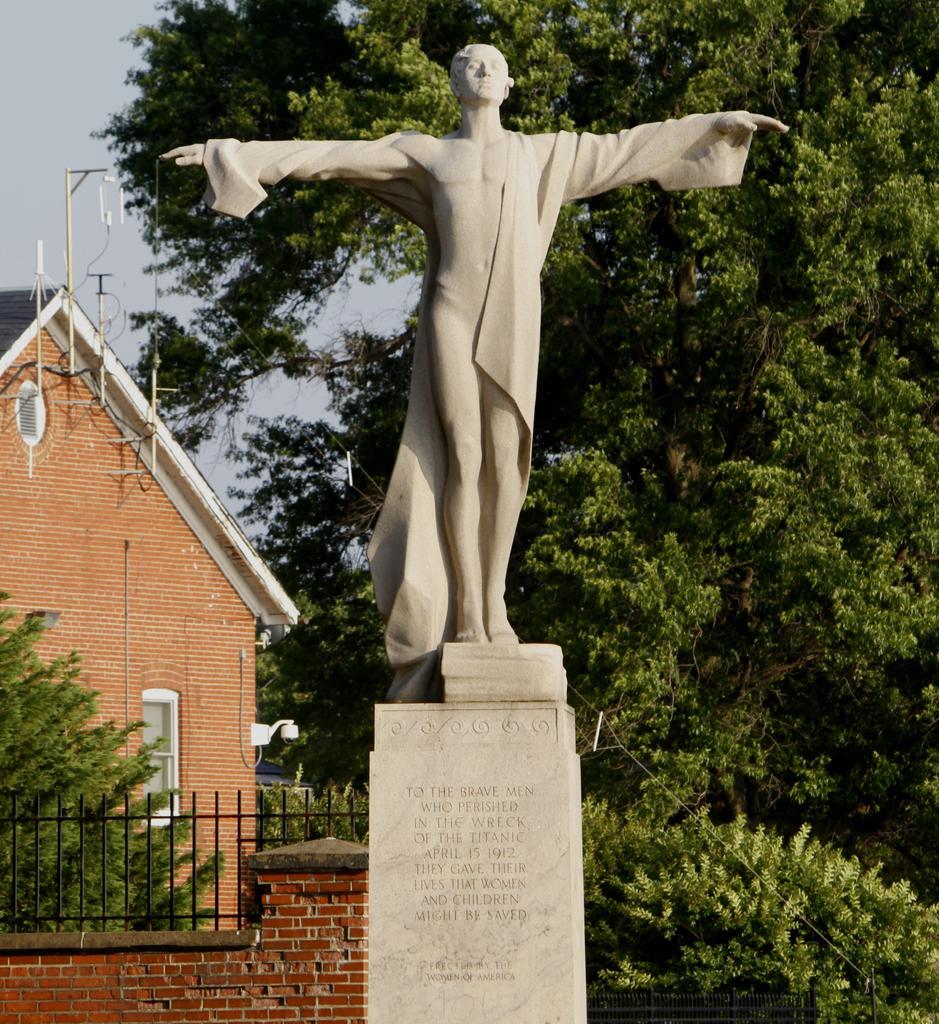Can you describe this image briefly? In this image I can see a statue of a person which is ash in color on the concrete pillar. In the background I can see the railing, the wall, few trees, a building and the sky. 